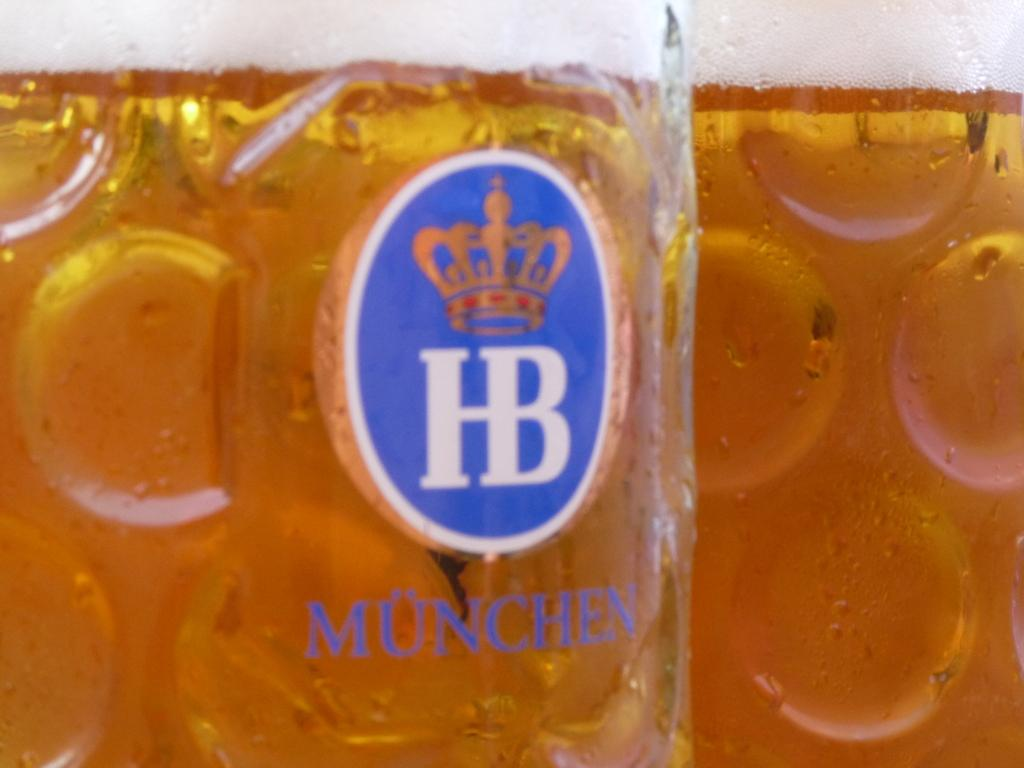<image>
Share a concise interpretation of the image provided. Cup of Munchen beer with a blue logo on it. 